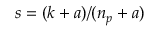Convert formula to latex. <formula><loc_0><loc_0><loc_500><loc_500>s = ( k + a ) / ( n _ { p } + a )</formula> 